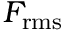Convert formula to latex. <formula><loc_0><loc_0><loc_500><loc_500>F _ { r m s }</formula> 